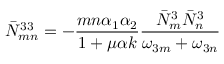Convert formula to latex. <formula><loc_0><loc_0><loc_500><loc_500>\bar { N } _ { m n } ^ { 3 3 } = - { \frac { m n \alpha _ { 1 } \alpha _ { 2 } } { 1 + \mu \alpha k } } { \frac { \bar { N } _ { m } ^ { 3 } \bar { N } _ { n } ^ { 3 } } { \omega _ { 3 m } + \omega _ { 3 n } } }</formula> 